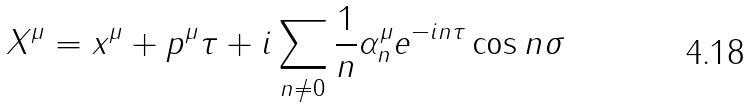<formula> <loc_0><loc_0><loc_500><loc_500>X ^ { \mu } = x ^ { \mu } + p ^ { \mu } \tau + i \sum _ { n \neq 0 } \frac { 1 } { n } \alpha _ { n } ^ { \mu } e ^ { - i n \tau } \cos n \sigma</formula> 